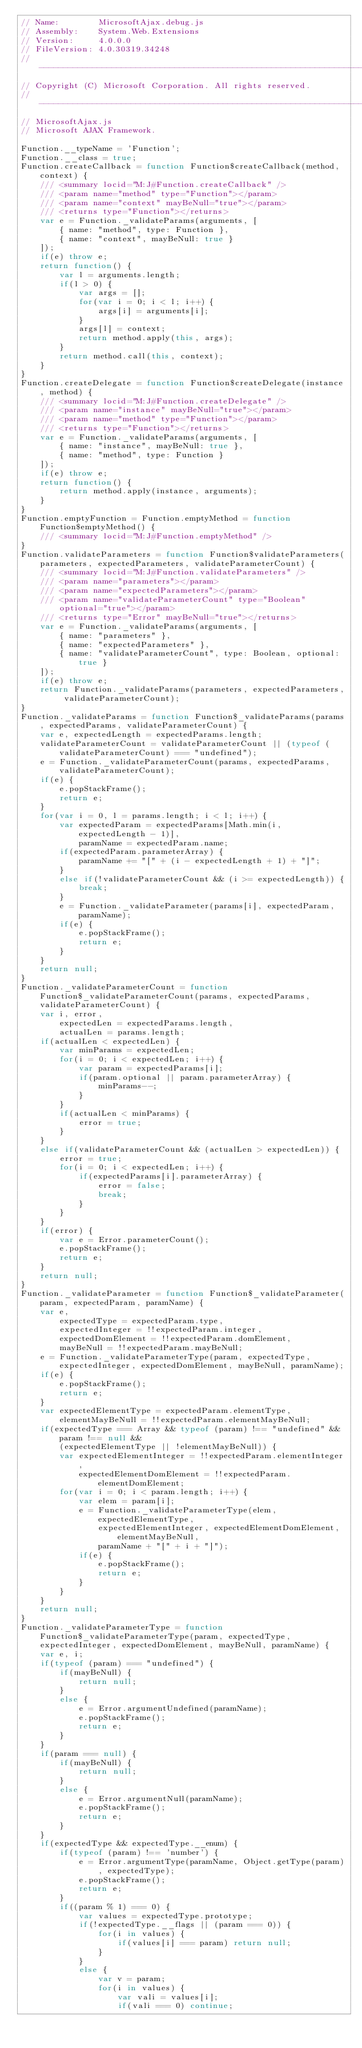<code> <loc_0><loc_0><loc_500><loc_500><_JavaScript_>// Name:        MicrosoftAjax.debug.js
// Assembly:    System.Web.Extensions
// Version:     4.0.0.0
// FileVersion: 4.0.30319.34248
//-----------------------------------------------------------------------
// Copyright (C) Microsoft Corporation. All rights reserved.
//-----------------------------------------------------------------------
// MicrosoftAjax.js
// Microsoft AJAX Framework.

Function.__typeName = 'Function';
Function.__class = true;
Function.createCallback = function Function$createCallback(method, context) {
    /// <summary locid="M:J#Function.createCallback" />
    /// <param name="method" type="Function"></param>
    /// <param name="context" mayBeNull="true"></param>
    /// <returns type="Function"></returns>
    var e = Function._validateParams(arguments, [
        { name: "method", type: Function },
        { name: "context", mayBeNull: true }
    ]);
    if(e) throw e;
    return function() {
        var l = arguments.length;
        if(l > 0) {
            var args = [];
            for(var i = 0; i < l; i++) {
                args[i] = arguments[i];
            }
            args[l] = context;
            return method.apply(this, args);
        }
        return method.call(this, context);
    }
}
Function.createDelegate = function Function$createDelegate(instance, method) {
    /// <summary locid="M:J#Function.createDelegate" />
    /// <param name="instance" mayBeNull="true"></param>
    /// <param name="method" type="Function"></param>
    /// <returns type="Function"></returns>
    var e = Function._validateParams(arguments, [
        { name: "instance", mayBeNull: true },
        { name: "method", type: Function }
    ]);
    if(e) throw e;
    return function() {
        return method.apply(instance, arguments);
    }
}
Function.emptyFunction = Function.emptyMethod = function Function$emptyMethod() {
    /// <summary locid="M:J#Function.emptyMethod" />
}
Function.validateParameters = function Function$validateParameters(parameters, expectedParameters, validateParameterCount) {
    /// <summary locid="M:J#Function.validateParameters" />
    /// <param name="parameters"></param>
    /// <param name="expectedParameters"></param>
    /// <param name="validateParameterCount" type="Boolean" optional="true"></param>
    /// <returns type="Error" mayBeNull="true"></returns>
    var e = Function._validateParams(arguments, [
        { name: "parameters" },
        { name: "expectedParameters" },
        { name: "validateParameterCount", type: Boolean, optional: true }
    ]);
    if(e) throw e;
    return Function._validateParams(parameters, expectedParameters, validateParameterCount);
}
Function._validateParams = function Function$_validateParams(params, expectedParams, validateParameterCount) {
    var e, expectedLength = expectedParams.length;
    validateParameterCount = validateParameterCount || (typeof (validateParameterCount) === "undefined");
    e = Function._validateParameterCount(params, expectedParams, validateParameterCount);
    if(e) {
        e.popStackFrame();
        return e;
    }
    for(var i = 0, l = params.length; i < l; i++) {
        var expectedParam = expectedParams[Math.min(i, expectedLength - 1)],
            paramName = expectedParam.name;
        if(expectedParam.parameterArray) {
            paramName += "[" + (i - expectedLength + 1) + "]";
        }
        else if(!validateParameterCount && (i >= expectedLength)) {
            break;
        }
        e = Function._validateParameter(params[i], expectedParam, paramName);
        if(e) {
            e.popStackFrame();
            return e;
        }
    }
    return null;
}
Function._validateParameterCount = function Function$_validateParameterCount(params, expectedParams, validateParameterCount) {
    var i, error,
        expectedLen = expectedParams.length,
        actualLen = params.length;
    if(actualLen < expectedLen) {
        var minParams = expectedLen;
        for(i = 0; i < expectedLen; i++) {
            var param = expectedParams[i];
            if(param.optional || param.parameterArray) {
                minParams--;
            }
        }
        if(actualLen < minParams) {
            error = true;
        }
    }
    else if(validateParameterCount && (actualLen > expectedLen)) {
        error = true;
        for(i = 0; i < expectedLen; i++) {
            if(expectedParams[i].parameterArray) {
                error = false;
                break;
            }
        }
    }
    if(error) {
        var e = Error.parameterCount();
        e.popStackFrame();
        return e;
    }
    return null;
}
Function._validateParameter = function Function$_validateParameter(param, expectedParam, paramName) {
    var e,
        expectedType = expectedParam.type,
        expectedInteger = !!expectedParam.integer,
        expectedDomElement = !!expectedParam.domElement,
        mayBeNull = !!expectedParam.mayBeNull;
    e = Function._validateParameterType(param, expectedType, expectedInteger, expectedDomElement, mayBeNull, paramName);
    if(e) {
        e.popStackFrame();
        return e;
    }
    var expectedElementType = expectedParam.elementType,
        elementMayBeNull = !!expectedParam.elementMayBeNull;
    if(expectedType === Array && typeof (param) !== "undefined" && param !== null &&
        (expectedElementType || !elementMayBeNull)) {
        var expectedElementInteger = !!expectedParam.elementInteger,
            expectedElementDomElement = !!expectedParam.elementDomElement;
        for(var i = 0; i < param.length; i++) {
            var elem = param[i];
            e = Function._validateParameterType(elem, expectedElementType,
                expectedElementInteger, expectedElementDomElement, elementMayBeNull,
                paramName + "[" + i + "]");
            if(e) {
                e.popStackFrame();
                return e;
            }
        }
    }
    return null;
}
Function._validateParameterType = function Function$_validateParameterType(param, expectedType, expectedInteger, expectedDomElement, mayBeNull, paramName) {
    var e, i;
    if(typeof (param) === "undefined") {
        if(mayBeNull) {
            return null;
        }
        else {
            e = Error.argumentUndefined(paramName);
            e.popStackFrame();
            return e;
        }
    }
    if(param === null) {
        if(mayBeNull) {
            return null;
        }
        else {
            e = Error.argumentNull(paramName);
            e.popStackFrame();
            return e;
        }
    }
    if(expectedType && expectedType.__enum) {
        if(typeof (param) !== 'number') {
            e = Error.argumentType(paramName, Object.getType(param), expectedType);
            e.popStackFrame();
            return e;
        }
        if((param % 1) === 0) {
            var values = expectedType.prototype;
            if(!expectedType.__flags || (param === 0)) {
                for(i in values) {
                    if(values[i] === param) return null;
                }
            }
            else {
                var v = param;
                for(i in values) {
                    var vali = values[i];
                    if(vali === 0) continue;</code> 